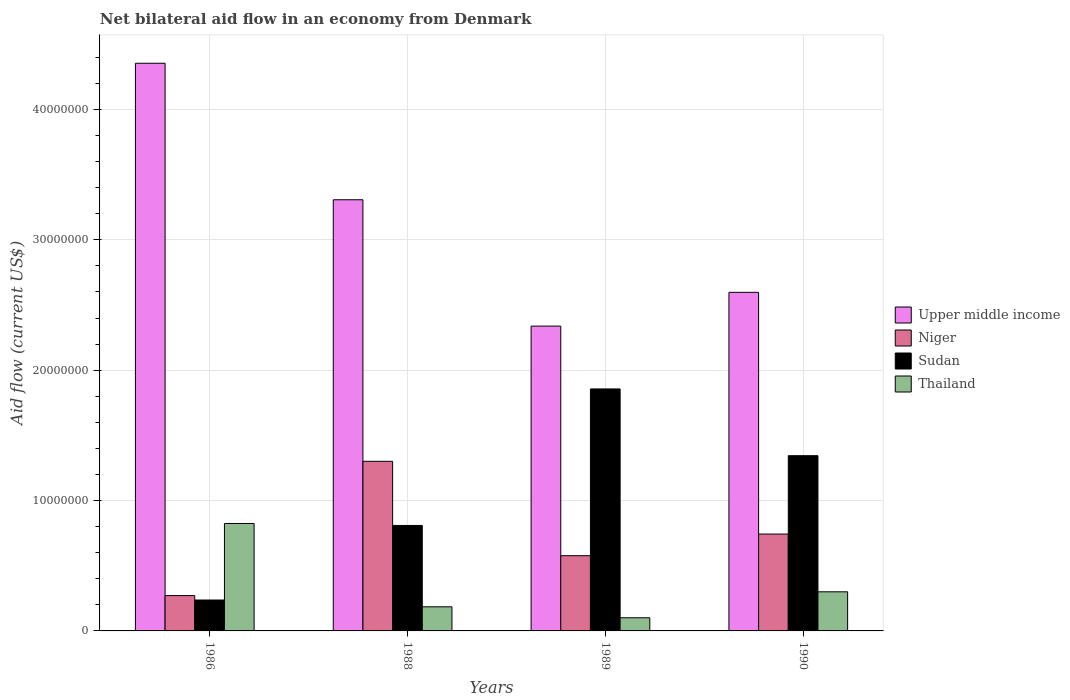How many groups of bars are there?
Provide a succinct answer. 4. Are the number of bars per tick equal to the number of legend labels?
Provide a succinct answer. Yes. Are the number of bars on each tick of the X-axis equal?
Give a very brief answer. Yes. How many bars are there on the 1st tick from the right?
Offer a terse response. 4. In how many cases, is the number of bars for a given year not equal to the number of legend labels?
Make the answer very short. 0. What is the net bilateral aid flow in Sudan in 1989?
Your answer should be compact. 1.86e+07. Across all years, what is the maximum net bilateral aid flow in Upper middle income?
Make the answer very short. 4.35e+07. Across all years, what is the minimum net bilateral aid flow in Upper middle income?
Give a very brief answer. 2.34e+07. In which year was the net bilateral aid flow in Niger maximum?
Your answer should be compact. 1988. What is the total net bilateral aid flow in Upper middle income in the graph?
Your answer should be compact. 1.26e+08. What is the difference between the net bilateral aid flow in Sudan in 1986 and that in 1988?
Ensure brevity in your answer.  -5.72e+06. What is the difference between the net bilateral aid flow in Niger in 1988 and the net bilateral aid flow in Upper middle income in 1989?
Make the answer very short. -1.04e+07. What is the average net bilateral aid flow in Niger per year?
Offer a very short reply. 7.23e+06. In the year 1988, what is the difference between the net bilateral aid flow in Sudan and net bilateral aid flow in Thailand?
Provide a short and direct response. 6.24e+06. What is the ratio of the net bilateral aid flow in Sudan in 1986 to that in 1988?
Ensure brevity in your answer.  0.29. Is the net bilateral aid flow in Sudan in 1986 less than that in 1988?
Keep it short and to the point. Yes. Is the difference between the net bilateral aid flow in Sudan in 1986 and 1988 greater than the difference between the net bilateral aid flow in Thailand in 1986 and 1988?
Your answer should be very brief. No. What is the difference between the highest and the second highest net bilateral aid flow in Niger?
Make the answer very short. 5.58e+06. What is the difference between the highest and the lowest net bilateral aid flow in Sudan?
Make the answer very short. 1.62e+07. Is the sum of the net bilateral aid flow in Sudan in 1986 and 1988 greater than the maximum net bilateral aid flow in Upper middle income across all years?
Ensure brevity in your answer.  No. Is it the case that in every year, the sum of the net bilateral aid flow in Sudan and net bilateral aid flow in Niger is greater than the sum of net bilateral aid flow in Upper middle income and net bilateral aid flow in Thailand?
Make the answer very short. No. What does the 4th bar from the left in 1986 represents?
Make the answer very short. Thailand. What does the 4th bar from the right in 1986 represents?
Make the answer very short. Upper middle income. Is it the case that in every year, the sum of the net bilateral aid flow in Thailand and net bilateral aid flow in Niger is greater than the net bilateral aid flow in Sudan?
Ensure brevity in your answer.  No. How many bars are there?
Offer a very short reply. 16. Are all the bars in the graph horizontal?
Provide a succinct answer. No. How are the legend labels stacked?
Provide a succinct answer. Vertical. What is the title of the graph?
Provide a succinct answer. Net bilateral aid flow in an economy from Denmark. What is the label or title of the X-axis?
Make the answer very short. Years. What is the Aid flow (current US$) in Upper middle income in 1986?
Your answer should be compact. 4.35e+07. What is the Aid flow (current US$) in Niger in 1986?
Your answer should be compact. 2.71e+06. What is the Aid flow (current US$) of Sudan in 1986?
Offer a very short reply. 2.37e+06. What is the Aid flow (current US$) in Thailand in 1986?
Your answer should be compact. 8.24e+06. What is the Aid flow (current US$) of Upper middle income in 1988?
Offer a very short reply. 3.31e+07. What is the Aid flow (current US$) of Niger in 1988?
Your response must be concise. 1.30e+07. What is the Aid flow (current US$) of Sudan in 1988?
Keep it short and to the point. 8.09e+06. What is the Aid flow (current US$) of Thailand in 1988?
Offer a terse response. 1.85e+06. What is the Aid flow (current US$) of Upper middle income in 1989?
Offer a terse response. 2.34e+07. What is the Aid flow (current US$) in Niger in 1989?
Provide a short and direct response. 5.77e+06. What is the Aid flow (current US$) in Sudan in 1989?
Your answer should be very brief. 1.86e+07. What is the Aid flow (current US$) in Thailand in 1989?
Ensure brevity in your answer.  1.01e+06. What is the Aid flow (current US$) of Upper middle income in 1990?
Offer a terse response. 2.60e+07. What is the Aid flow (current US$) of Niger in 1990?
Offer a very short reply. 7.43e+06. What is the Aid flow (current US$) of Sudan in 1990?
Keep it short and to the point. 1.34e+07. Across all years, what is the maximum Aid flow (current US$) in Upper middle income?
Your answer should be very brief. 4.35e+07. Across all years, what is the maximum Aid flow (current US$) of Niger?
Provide a short and direct response. 1.30e+07. Across all years, what is the maximum Aid flow (current US$) of Sudan?
Make the answer very short. 1.86e+07. Across all years, what is the maximum Aid flow (current US$) of Thailand?
Your response must be concise. 8.24e+06. Across all years, what is the minimum Aid flow (current US$) of Upper middle income?
Keep it short and to the point. 2.34e+07. Across all years, what is the minimum Aid flow (current US$) of Niger?
Ensure brevity in your answer.  2.71e+06. Across all years, what is the minimum Aid flow (current US$) in Sudan?
Your answer should be very brief. 2.37e+06. Across all years, what is the minimum Aid flow (current US$) in Thailand?
Give a very brief answer. 1.01e+06. What is the total Aid flow (current US$) in Upper middle income in the graph?
Give a very brief answer. 1.26e+08. What is the total Aid flow (current US$) in Niger in the graph?
Provide a succinct answer. 2.89e+07. What is the total Aid flow (current US$) in Sudan in the graph?
Ensure brevity in your answer.  4.25e+07. What is the total Aid flow (current US$) of Thailand in the graph?
Offer a very short reply. 1.41e+07. What is the difference between the Aid flow (current US$) of Upper middle income in 1986 and that in 1988?
Your answer should be compact. 1.05e+07. What is the difference between the Aid flow (current US$) of Niger in 1986 and that in 1988?
Your answer should be compact. -1.03e+07. What is the difference between the Aid flow (current US$) in Sudan in 1986 and that in 1988?
Provide a short and direct response. -5.72e+06. What is the difference between the Aid flow (current US$) of Thailand in 1986 and that in 1988?
Offer a very short reply. 6.39e+06. What is the difference between the Aid flow (current US$) of Upper middle income in 1986 and that in 1989?
Give a very brief answer. 2.02e+07. What is the difference between the Aid flow (current US$) of Niger in 1986 and that in 1989?
Provide a short and direct response. -3.06e+06. What is the difference between the Aid flow (current US$) of Sudan in 1986 and that in 1989?
Your answer should be very brief. -1.62e+07. What is the difference between the Aid flow (current US$) of Thailand in 1986 and that in 1989?
Provide a short and direct response. 7.23e+06. What is the difference between the Aid flow (current US$) in Upper middle income in 1986 and that in 1990?
Provide a short and direct response. 1.76e+07. What is the difference between the Aid flow (current US$) of Niger in 1986 and that in 1990?
Make the answer very short. -4.72e+06. What is the difference between the Aid flow (current US$) of Sudan in 1986 and that in 1990?
Offer a terse response. -1.11e+07. What is the difference between the Aid flow (current US$) of Thailand in 1986 and that in 1990?
Your response must be concise. 5.24e+06. What is the difference between the Aid flow (current US$) of Upper middle income in 1988 and that in 1989?
Your answer should be compact. 9.69e+06. What is the difference between the Aid flow (current US$) in Niger in 1988 and that in 1989?
Your response must be concise. 7.24e+06. What is the difference between the Aid flow (current US$) of Sudan in 1988 and that in 1989?
Offer a terse response. -1.05e+07. What is the difference between the Aid flow (current US$) of Thailand in 1988 and that in 1989?
Ensure brevity in your answer.  8.40e+05. What is the difference between the Aid flow (current US$) in Upper middle income in 1988 and that in 1990?
Offer a terse response. 7.10e+06. What is the difference between the Aid flow (current US$) of Niger in 1988 and that in 1990?
Keep it short and to the point. 5.58e+06. What is the difference between the Aid flow (current US$) in Sudan in 1988 and that in 1990?
Make the answer very short. -5.35e+06. What is the difference between the Aid flow (current US$) in Thailand in 1988 and that in 1990?
Offer a terse response. -1.15e+06. What is the difference between the Aid flow (current US$) in Upper middle income in 1989 and that in 1990?
Give a very brief answer. -2.59e+06. What is the difference between the Aid flow (current US$) in Niger in 1989 and that in 1990?
Provide a short and direct response. -1.66e+06. What is the difference between the Aid flow (current US$) in Sudan in 1989 and that in 1990?
Provide a short and direct response. 5.12e+06. What is the difference between the Aid flow (current US$) of Thailand in 1989 and that in 1990?
Your answer should be very brief. -1.99e+06. What is the difference between the Aid flow (current US$) in Upper middle income in 1986 and the Aid flow (current US$) in Niger in 1988?
Offer a terse response. 3.05e+07. What is the difference between the Aid flow (current US$) in Upper middle income in 1986 and the Aid flow (current US$) in Sudan in 1988?
Offer a terse response. 3.54e+07. What is the difference between the Aid flow (current US$) in Upper middle income in 1986 and the Aid flow (current US$) in Thailand in 1988?
Your response must be concise. 4.17e+07. What is the difference between the Aid flow (current US$) of Niger in 1986 and the Aid flow (current US$) of Sudan in 1988?
Offer a very short reply. -5.38e+06. What is the difference between the Aid flow (current US$) in Niger in 1986 and the Aid flow (current US$) in Thailand in 1988?
Your answer should be very brief. 8.60e+05. What is the difference between the Aid flow (current US$) of Sudan in 1986 and the Aid flow (current US$) of Thailand in 1988?
Provide a succinct answer. 5.20e+05. What is the difference between the Aid flow (current US$) of Upper middle income in 1986 and the Aid flow (current US$) of Niger in 1989?
Make the answer very short. 3.78e+07. What is the difference between the Aid flow (current US$) in Upper middle income in 1986 and the Aid flow (current US$) in Sudan in 1989?
Make the answer very short. 2.50e+07. What is the difference between the Aid flow (current US$) of Upper middle income in 1986 and the Aid flow (current US$) of Thailand in 1989?
Provide a short and direct response. 4.25e+07. What is the difference between the Aid flow (current US$) in Niger in 1986 and the Aid flow (current US$) in Sudan in 1989?
Provide a succinct answer. -1.58e+07. What is the difference between the Aid flow (current US$) of Niger in 1986 and the Aid flow (current US$) of Thailand in 1989?
Give a very brief answer. 1.70e+06. What is the difference between the Aid flow (current US$) of Sudan in 1986 and the Aid flow (current US$) of Thailand in 1989?
Your response must be concise. 1.36e+06. What is the difference between the Aid flow (current US$) in Upper middle income in 1986 and the Aid flow (current US$) in Niger in 1990?
Your response must be concise. 3.61e+07. What is the difference between the Aid flow (current US$) in Upper middle income in 1986 and the Aid flow (current US$) in Sudan in 1990?
Your response must be concise. 3.01e+07. What is the difference between the Aid flow (current US$) in Upper middle income in 1986 and the Aid flow (current US$) in Thailand in 1990?
Offer a terse response. 4.05e+07. What is the difference between the Aid flow (current US$) in Niger in 1986 and the Aid flow (current US$) in Sudan in 1990?
Offer a terse response. -1.07e+07. What is the difference between the Aid flow (current US$) of Sudan in 1986 and the Aid flow (current US$) of Thailand in 1990?
Your answer should be very brief. -6.30e+05. What is the difference between the Aid flow (current US$) of Upper middle income in 1988 and the Aid flow (current US$) of Niger in 1989?
Offer a terse response. 2.73e+07. What is the difference between the Aid flow (current US$) of Upper middle income in 1988 and the Aid flow (current US$) of Sudan in 1989?
Make the answer very short. 1.45e+07. What is the difference between the Aid flow (current US$) of Upper middle income in 1988 and the Aid flow (current US$) of Thailand in 1989?
Ensure brevity in your answer.  3.21e+07. What is the difference between the Aid flow (current US$) in Niger in 1988 and the Aid flow (current US$) in Sudan in 1989?
Keep it short and to the point. -5.55e+06. What is the difference between the Aid flow (current US$) of Niger in 1988 and the Aid flow (current US$) of Thailand in 1989?
Your answer should be compact. 1.20e+07. What is the difference between the Aid flow (current US$) in Sudan in 1988 and the Aid flow (current US$) in Thailand in 1989?
Your answer should be compact. 7.08e+06. What is the difference between the Aid flow (current US$) of Upper middle income in 1988 and the Aid flow (current US$) of Niger in 1990?
Your response must be concise. 2.56e+07. What is the difference between the Aid flow (current US$) of Upper middle income in 1988 and the Aid flow (current US$) of Sudan in 1990?
Make the answer very short. 1.96e+07. What is the difference between the Aid flow (current US$) in Upper middle income in 1988 and the Aid flow (current US$) in Thailand in 1990?
Give a very brief answer. 3.01e+07. What is the difference between the Aid flow (current US$) of Niger in 1988 and the Aid flow (current US$) of Sudan in 1990?
Give a very brief answer. -4.30e+05. What is the difference between the Aid flow (current US$) of Niger in 1988 and the Aid flow (current US$) of Thailand in 1990?
Give a very brief answer. 1.00e+07. What is the difference between the Aid flow (current US$) of Sudan in 1988 and the Aid flow (current US$) of Thailand in 1990?
Keep it short and to the point. 5.09e+06. What is the difference between the Aid flow (current US$) in Upper middle income in 1989 and the Aid flow (current US$) in Niger in 1990?
Ensure brevity in your answer.  1.60e+07. What is the difference between the Aid flow (current US$) in Upper middle income in 1989 and the Aid flow (current US$) in Sudan in 1990?
Your response must be concise. 9.94e+06. What is the difference between the Aid flow (current US$) in Upper middle income in 1989 and the Aid flow (current US$) in Thailand in 1990?
Your answer should be very brief. 2.04e+07. What is the difference between the Aid flow (current US$) in Niger in 1989 and the Aid flow (current US$) in Sudan in 1990?
Your response must be concise. -7.67e+06. What is the difference between the Aid flow (current US$) in Niger in 1989 and the Aid flow (current US$) in Thailand in 1990?
Offer a terse response. 2.77e+06. What is the difference between the Aid flow (current US$) of Sudan in 1989 and the Aid flow (current US$) of Thailand in 1990?
Your response must be concise. 1.56e+07. What is the average Aid flow (current US$) of Upper middle income per year?
Keep it short and to the point. 3.15e+07. What is the average Aid flow (current US$) of Niger per year?
Give a very brief answer. 7.23e+06. What is the average Aid flow (current US$) of Sudan per year?
Give a very brief answer. 1.06e+07. What is the average Aid flow (current US$) in Thailand per year?
Offer a terse response. 3.52e+06. In the year 1986, what is the difference between the Aid flow (current US$) of Upper middle income and Aid flow (current US$) of Niger?
Ensure brevity in your answer.  4.08e+07. In the year 1986, what is the difference between the Aid flow (current US$) of Upper middle income and Aid flow (current US$) of Sudan?
Keep it short and to the point. 4.12e+07. In the year 1986, what is the difference between the Aid flow (current US$) of Upper middle income and Aid flow (current US$) of Thailand?
Your response must be concise. 3.53e+07. In the year 1986, what is the difference between the Aid flow (current US$) in Niger and Aid flow (current US$) in Sudan?
Ensure brevity in your answer.  3.40e+05. In the year 1986, what is the difference between the Aid flow (current US$) in Niger and Aid flow (current US$) in Thailand?
Offer a terse response. -5.53e+06. In the year 1986, what is the difference between the Aid flow (current US$) in Sudan and Aid flow (current US$) in Thailand?
Provide a succinct answer. -5.87e+06. In the year 1988, what is the difference between the Aid flow (current US$) of Upper middle income and Aid flow (current US$) of Niger?
Provide a short and direct response. 2.01e+07. In the year 1988, what is the difference between the Aid flow (current US$) of Upper middle income and Aid flow (current US$) of Sudan?
Give a very brief answer. 2.50e+07. In the year 1988, what is the difference between the Aid flow (current US$) of Upper middle income and Aid flow (current US$) of Thailand?
Give a very brief answer. 3.12e+07. In the year 1988, what is the difference between the Aid flow (current US$) in Niger and Aid flow (current US$) in Sudan?
Keep it short and to the point. 4.92e+06. In the year 1988, what is the difference between the Aid flow (current US$) of Niger and Aid flow (current US$) of Thailand?
Make the answer very short. 1.12e+07. In the year 1988, what is the difference between the Aid flow (current US$) in Sudan and Aid flow (current US$) in Thailand?
Provide a succinct answer. 6.24e+06. In the year 1989, what is the difference between the Aid flow (current US$) of Upper middle income and Aid flow (current US$) of Niger?
Ensure brevity in your answer.  1.76e+07. In the year 1989, what is the difference between the Aid flow (current US$) in Upper middle income and Aid flow (current US$) in Sudan?
Ensure brevity in your answer.  4.82e+06. In the year 1989, what is the difference between the Aid flow (current US$) of Upper middle income and Aid flow (current US$) of Thailand?
Give a very brief answer. 2.24e+07. In the year 1989, what is the difference between the Aid flow (current US$) in Niger and Aid flow (current US$) in Sudan?
Keep it short and to the point. -1.28e+07. In the year 1989, what is the difference between the Aid flow (current US$) of Niger and Aid flow (current US$) of Thailand?
Give a very brief answer. 4.76e+06. In the year 1989, what is the difference between the Aid flow (current US$) in Sudan and Aid flow (current US$) in Thailand?
Your answer should be very brief. 1.76e+07. In the year 1990, what is the difference between the Aid flow (current US$) in Upper middle income and Aid flow (current US$) in Niger?
Give a very brief answer. 1.85e+07. In the year 1990, what is the difference between the Aid flow (current US$) of Upper middle income and Aid flow (current US$) of Sudan?
Your answer should be compact. 1.25e+07. In the year 1990, what is the difference between the Aid flow (current US$) in Upper middle income and Aid flow (current US$) in Thailand?
Your answer should be compact. 2.30e+07. In the year 1990, what is the difference between the Aid flow (current US$) of Niger and Aid flow (current US$) of Sudan?
Ensure brevity in your answer.  -6.01e+06. In the year 1990, what is the difference between the Aid flow (current US$) in Niger and Aid flow (current US$) in Thailand?
Keep it short and to the point. 4.43e+06. In the year 1990, what is the difference between the Aid flow (current US$) in Sudan and Aid flow (current US$) in Thailand?
Offer a terse response. 1.04e+07. What is the ratio of the Aid flow (current US$) in Upper middle income in 1986 to that in 1988?
Provide a short and direct response. 1.32. What is the ratio of the Aid flow (current US$) in Niger in 1986 to that in 1988?
Ensure brevity in your answer.  0.21. What is the ratio of the Aid flow (current US$) in Sudan in 1986 to that in 1988?
Your answer should be compact. 0.29. What is the ratio of the Aid flow (current US$) in Thailand in 1986 to that in 1988?
Offer a terse response. 4.45. What is the ratio of the Aid flow (current US$) of Upper middle income in 1986 to that in 1989?
Make the answer very short. 1.86. What is the ratio of the Aid flow (current US$) of Niger in 1986 to that in 1989?
Give a very brief answer. 0.47. What is the ratio of the Aid flow (current US$) of Sudan in 1986 to that in 1989?
Offer a terse response. 0.13. What is the ratio of the Aid flow (current US$) in Thailand in 1986 to that in 1989?
Provide a short and direct response. 8.16. What is the ratio of the Aid flow (current US$) in Upper middle income in 1986 to that in 1990?
Your response must be concise. 1.68. What is the ratio of the Aid flow (current US$) of Niger in 1986 to that in 1990?
Offer a very short reply. 0.36. What is the ratio of the Aid flow (current US$) in Sudan in 1986 to that in 1990?
Provide a succinct answer. 0.18. What is the ratio of the Aid flow (current US$) of Thailand in 1986 to that in 1990?
Provide a short and direct response. 2.75. What is the ratio of the Aid flow (current US$) of Upper middle income in 1988 to that in 1989?
Your response must be concise. 1.41. What is the ratio of the Aid flow (current US$) of Niger in 1988 to that in 1989?
Provide a short and direct response. 2.25. What is the ratio of the Aid flow (current US$) of Sudan in 1988 to that in 1989?
Give a very brief answer. 0.44. What is the ratio of the Aid flow (current US$) in Thailand in 1988 to that in 1989?
Your answer should be compact. 1.83. What is the ratio of the Aid flow (current US$) of Upper middle income in 1988 to that in 1990?
Make the answer very short. 1.27. What is the ratio of the Aid flow (current US$) in Niger in 1988 to that in 1990?
Your answer should be very brief. 1.75. What is the ratio of the Aid flow (current US$) of Sudan in 1988 to that in 1990?
Make the answer very short. 0.6. What is the ratio of the Aid flow (current US$) of Thailand in 1988 to that in 1990?
Provide a succinct answer. 0.62. What is the ratio of the Aid flow (current US$) in Upper middle income in 1989 to that in 1990?
Provide a short and direct response. 0.9. What is the ratio of the Aid flow (current US$) in Niger in 1989 to that in 1990?
Give a very brief answer. 0.78. What is the ratio of the Aid flow (current US$) in Sudan in 1989 to that in 1990?
Your answer should be very brief. 1.38. What is the ratio of the Aid flow (current US$) in Thailand in 1989 to that in 1990?
Your answer should be compact. 0.34. What is the difference between the highest and the second highest Aid flow (current US$) in Upper middle income?
Your response must be concise. 1.05e+07. What is the difference between the highest and the second highest Aid flow (current US$) of Niger?
Your answer should be compact. 5.58e+06. What is the difference between the highest and the second highest Aid flow (current US$) of Sudan?
Provide a succinct answer. 5.12e+06. What is the difference between the highest and the second highest Aid flow (current US$) in Thailand?
Keep it short and to the point. 5.24e+06. What is the difference between the highest and the lowest Aid flow (current US$) of Upper middle income?
Make the answer very short. 2.02e+07. What is the difference between the highest and the lowest Aid flow (current US$) in Niger?
Provide a short and direct response. 1.03e+07. What is the difference between the highest and the lowest Aid flow (current US$) of Sudan?
Keep it short and to the point. 1.62e+07. What is the difference between the highest and the lowest Aid flow (current US$) of Thailand?
Give a very brief answer. 7.23e+06. 